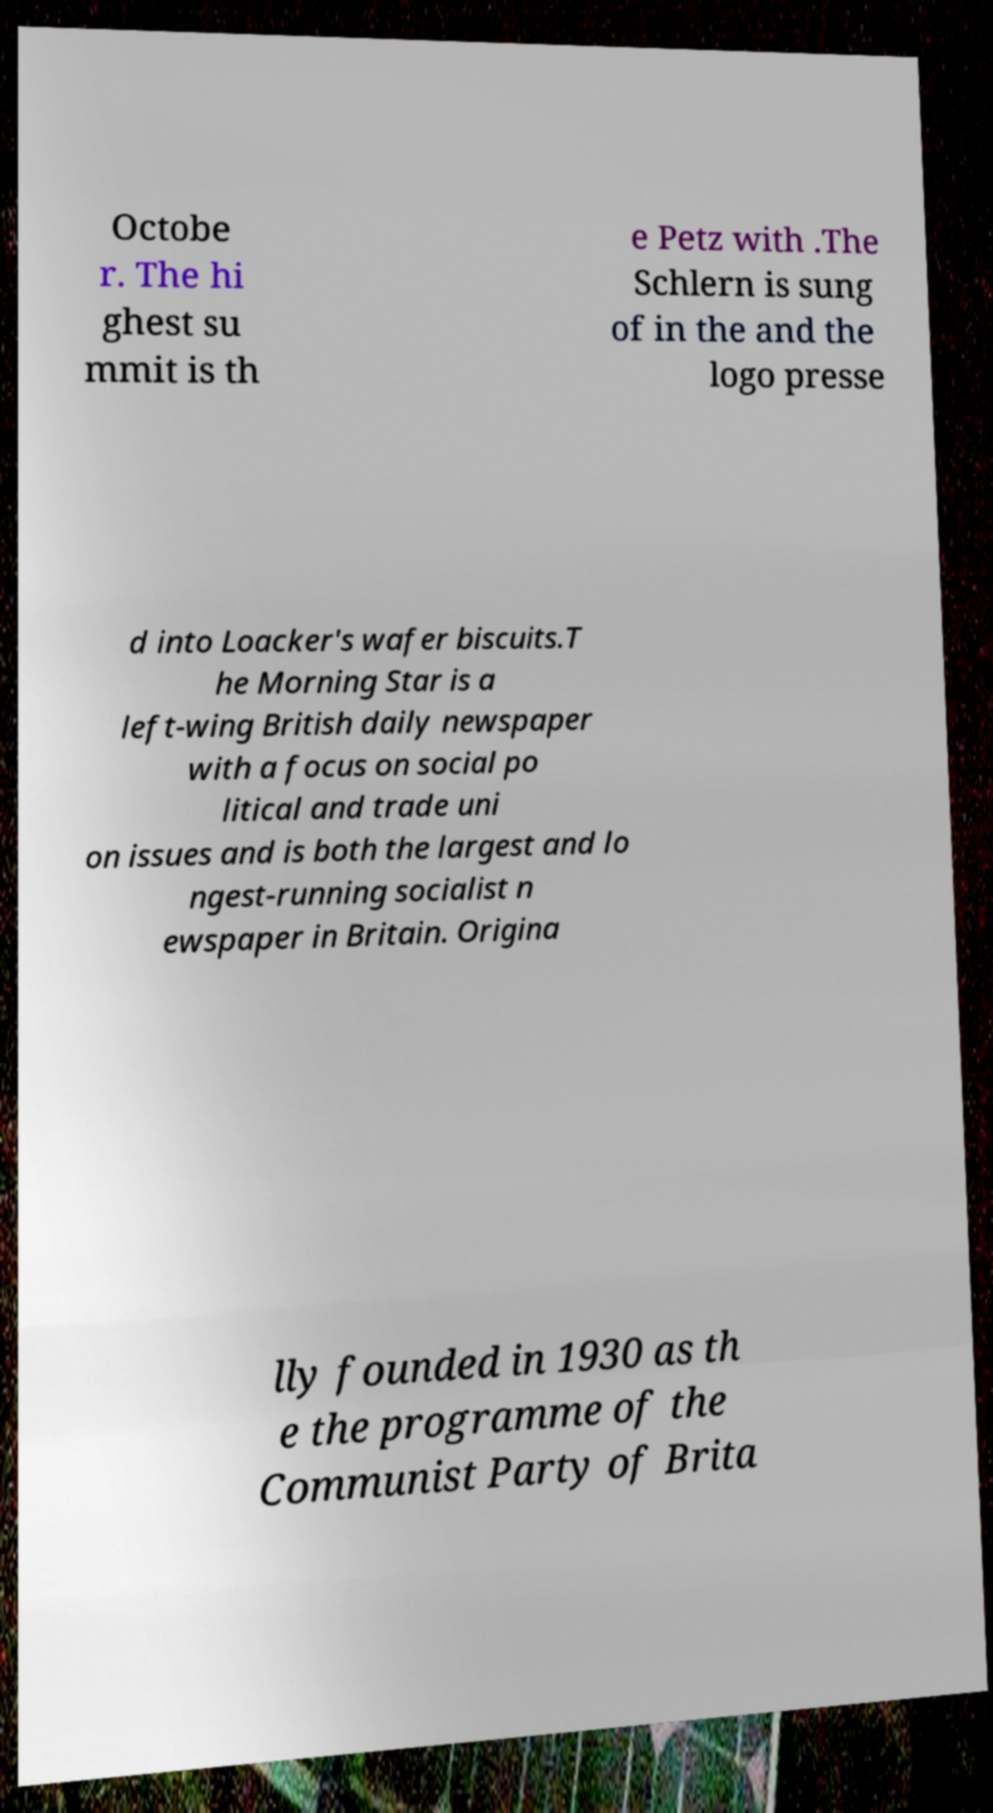Can you accurately transcribe the text from the provided image for me? Octobe r. The hi ghest su mmit is th e Petz with .The Schlern is sung of in the and the logo presse d into Loacker's wafer biscuits.T he Morning Star is a left-wing British daily newspaper with a focus on social po litical and trade uni on issues and is both the largest and lo ngest-running socialist n ewspaper in Britain. Origina lly founded in 1930 as th e the programme of the Communist Party of Brita 